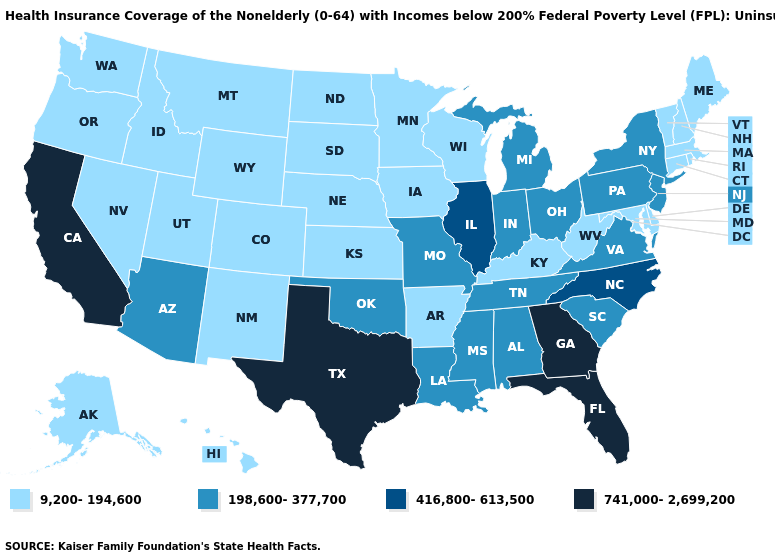Which states have the highest value in the USA?
Give a very brief answer. California, Florida, Georgia, Texas. Among the states that border Ohio , which have the lowest value?
Concise answer only. Kentucky, West Virginia. What is the value of New Hampshire?
Be succinct. 9,200-194,600. What is the value of Ohio?
Concise answer only. 198,600-377,700. What is the value of Montana?
Keep it brief. 9,200-194,600. Name the states that have a value in the range 416,800-613,500?
Quick response, please. Illinois, North Carolina. What is the highest value in states that border Delaware?
Keep it brief. 198,600-377,700. What is the value of Maryland?
Give a very brief answer. 9,200-194,600. Name the states that have a value in the range 198,600-377,700?
Give a very brief answer. Alabama, Arizona, Indiana, Louisiana, Michigan, Mississippi, Missouri, New Jersey, New York, Ohio, Oklahoma, Pennsylvania, South Carolina, Tennessee, Virginia. Which states have the highest value in the USA?
Give a very brief answer. California, Florida, Georgia, Texas. Among the states that border Maryland , does West Virginia have the highest value?
Keep it brief. No. Name the states that have a value in the range 198,600-377,700?
Short answer required. Alabama, Arizona, Indiana, Louisiana, Michigan, Mississippi, Missouri, New Jersey, New York, Ohio, Oklahoma, Pennsylvania, South Carolina, Tennessee, Virginia. Does Maine have the highest value in the Northeast?
Keep it brief. No. What is the value of Oklahoma?
Keep it brief. 198,600-377,700. Is the legend a continuous bar?
Give a very brief answer. No. 